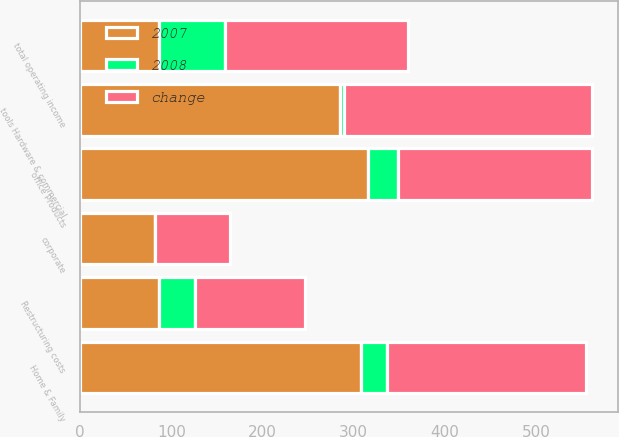<chart> <loc_0><loc_0><loc_500><loc_500><stacked_bar_chart><ecel><fcel>Home & Family<fcel>office Products<fcel>tools Hardware & commercial<fcel>corporate<fcel>Restructuring costs<fcel>total operating income<nl><fcel>change<fcel>218.3<fcel>212.4<fcel>271.7<fcel>81.9<fcel>120.3<fcel>200.8<nl><fcel>2007<fcel>307.5<fcel>315.8<fcel>285<fcel>82<fcel>86<fcel>86<nl><fcel>2008<fcel>29<fcel>32.7<fcel>4.7<fcel>0.1<fcel>39.9<fcel>72.9<nl></chart> 